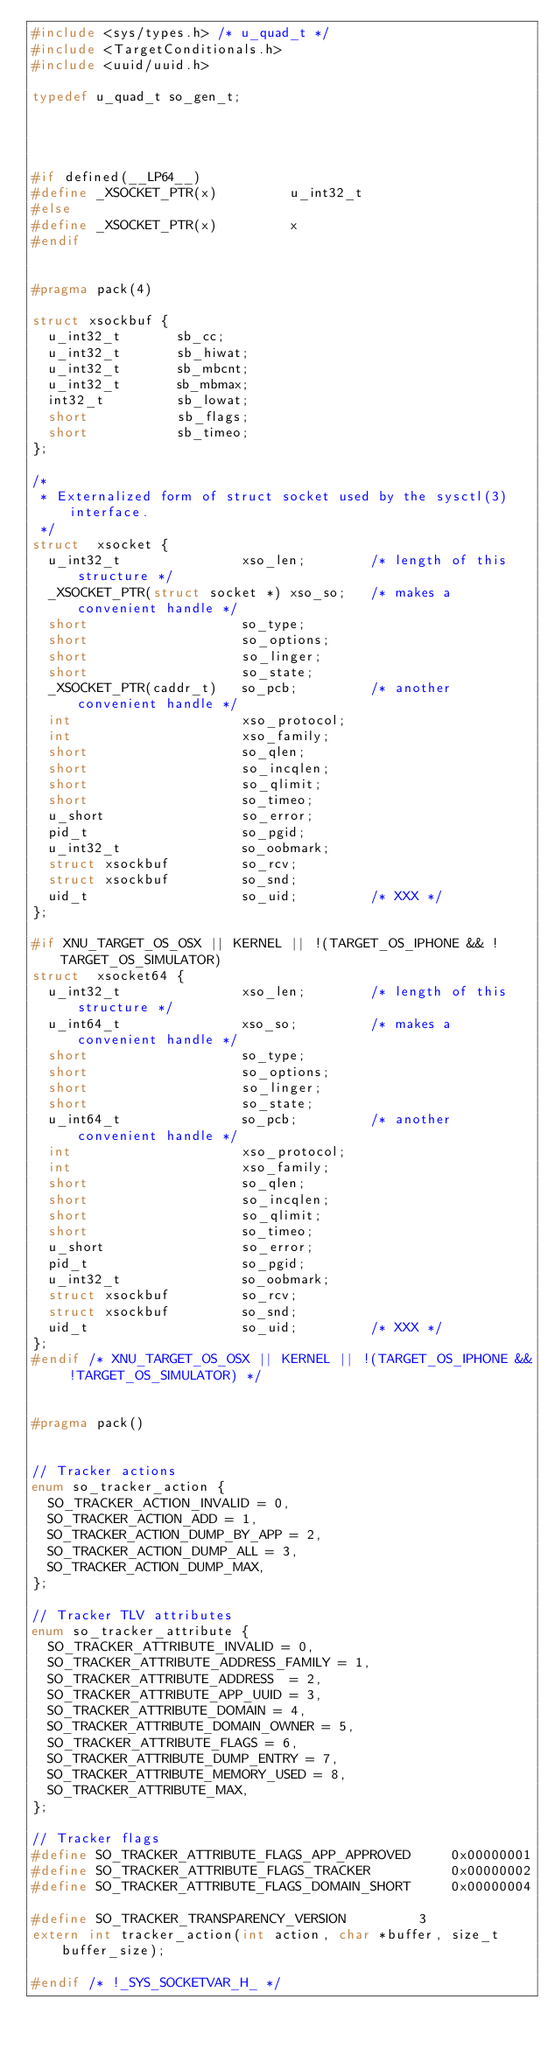Convert code to text. <code><loc_0><loc_0><loc_500><loc_500><_C_>#include <sys/types.h> /* u_quad_t */
#include <TargetConditionals.h>
#include <uuid/uuid.h>

typedef u_quad_t so_gen_t;




#if defined(__LP64__)
#define _XSOCKET_PTR(x)         u_int32_t
#else
#define _XSOCKET_PTR(x)         x
#endif


#pragma pack(4)

struct xsockbuf {
	u_int32_t       sb_cc;
	u_int32_t       sb_hiwat;
	u_int32_t       sb_mbcnt;
	u_int32_t       sb_mbmax;
	int32_t         sb_lowat;
	short           sb_flags;
	short           sb_timeo;
};

/*
 * Externalized form of struct socket used by the sysctl(3) interface.
 */
struct  xsocket {
	u_int32_t               xso_len;        /* length of this structure */
	_XSOCKET_PTR(struct socket *) xso_so;   /* makes a convenient handle */
	short                   so_type;
	short                   so_options;
	short                   so_linger;
	short                   so_state;
	_XSOCKET_PTR(caddr_t)   so_pcb;         /* another convenient handle */
	int                     xso_protocol;
	int                     xso_family;
	short                   so_qlen;
	short                   so_incqlen;
	short                   so_qlimit;
	short                   so_timeo;
	u_short                 so_error;
	pid_t                   so_pgid;
	u_int32_t               so_oobmark;
	struct xsockbuf         so_rcv;
	struct xsockbuf         so_snd;
	uid_t                   so_uid;         /* XXX */
};

#if XNU_TARGET_OS_OSX || KERNEL || !(TARGET_OS_IPHONE && !TARGET_OS_SIMULATOR)
struct  xsocket64 {
	u_int32_t               xso_len;        /* length of this structure */
	u_int64_t               xso_so;         /* makes a convenient handle */
	short                   so_type;
	short                   so_options;
	short                   so_linger;
	short                   so_state;
	u_int64_t               so_pcb;         /* another convenient handle */
	int                     xso_protocol;
	int                     xso_family;
	short                   so_qlen;
	short                   so_incqlen;
	short                   so_qlimit;
	short                   so_timeo;
	u_short                 so_error;
	pid_t                   so_pgid;
	u_int32_t               so_oobmark;
	struct xsockbuf         so_rcv;
	struct xsockbuf         so_snd;
	uid_t                   so_uid;         /* XXX */
};
#endif /* XNU_TARGET_OS_OSX || KERNEL || !(TARGET_OS_IPHONE && !TARGET_OS_SIMULATOR) */


#pragma pack()


// Tracker actions
enum so_tracker_action {
	SO_TRACKER_ACTION_INVALID = 0,
	SO_TRACKER_ACTION_ADD = 1,
	SO_TRACKER_ACTION_DUMP_BY_APP = 2,
	SO_TRACKER_ACTION_DUMP_ALL = 3,
	SO_TRACKER_ACTION_DUMP_MAX,
};

// Tracker TLV attributes
enum so_tracker_attribute {
	SO_TRACKER_ATTRIBUTE_INVALID = 0,
	SO_TRACKER_ATTRIBUTE_ADDRESS_FAMILY = 1,
	SO_TRACKER_ATTRIBUTE_ADDRESS  = 2,
	SO_TRACKER_ATTRIBUTE_APP_UUID = 3,
	SO_TRACKER_ATTRIBUTE_DOMAIN = 4,
	SO_TRACKER_ATTRIBUTE_DOMAIN_OWNER = 5,
	SO_TRACKER_ATTRIBUTE_FLAGS = 6,
	SO_TRACKER_ATTRIBUTE_DUMP_ENTRY = 7,
	SO_TRACKER_ATTRIBUTE_MEMORY_USED = 8,
	SO_TRACKER_ATTRIBUTE_MAX,
};

// Tracker flags
#define SO_TRACKER_ATTRIBUTE_FLAGS_APP_APPROVED     0x00000001
#define SO_TRACKER_ATTRIBUTE_FLAGS_TRACKER          0x00000002
#define SO_TRACKER_ATTRIBUTE_FLAGS_DOMAIN_SHORT     0x00000004

#define SO_TRACKER_TRANSPARENCY_VERSION         3
extern int tracker_action(int action, char *buffer, size_t buffer_size);

#endif /* !_SYS_SOCKETVAR_H_ */
</code> 